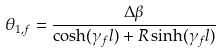<formula> <loc_0><loc_0><loc_500><loc_500>\theta _ { 1 , f } = \frac { \Delta \beta } { \cosh ( \gamma _ { f } l ) + R \sinh ( \gamma _ { f } l ) }</formula> 